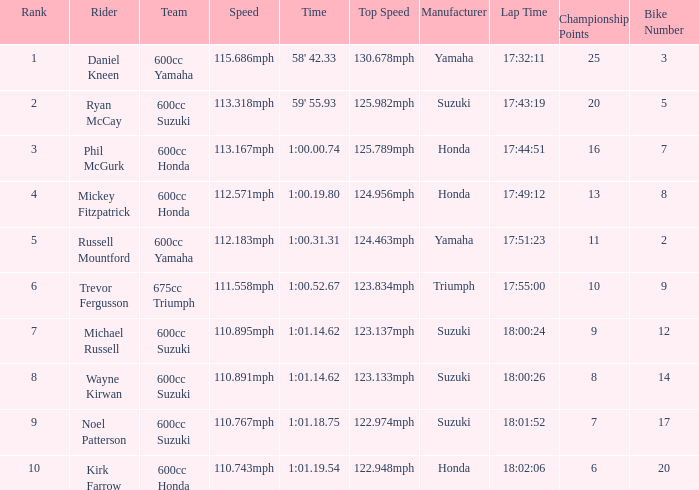How many ranks have michael russell as the rider? 7.0. 